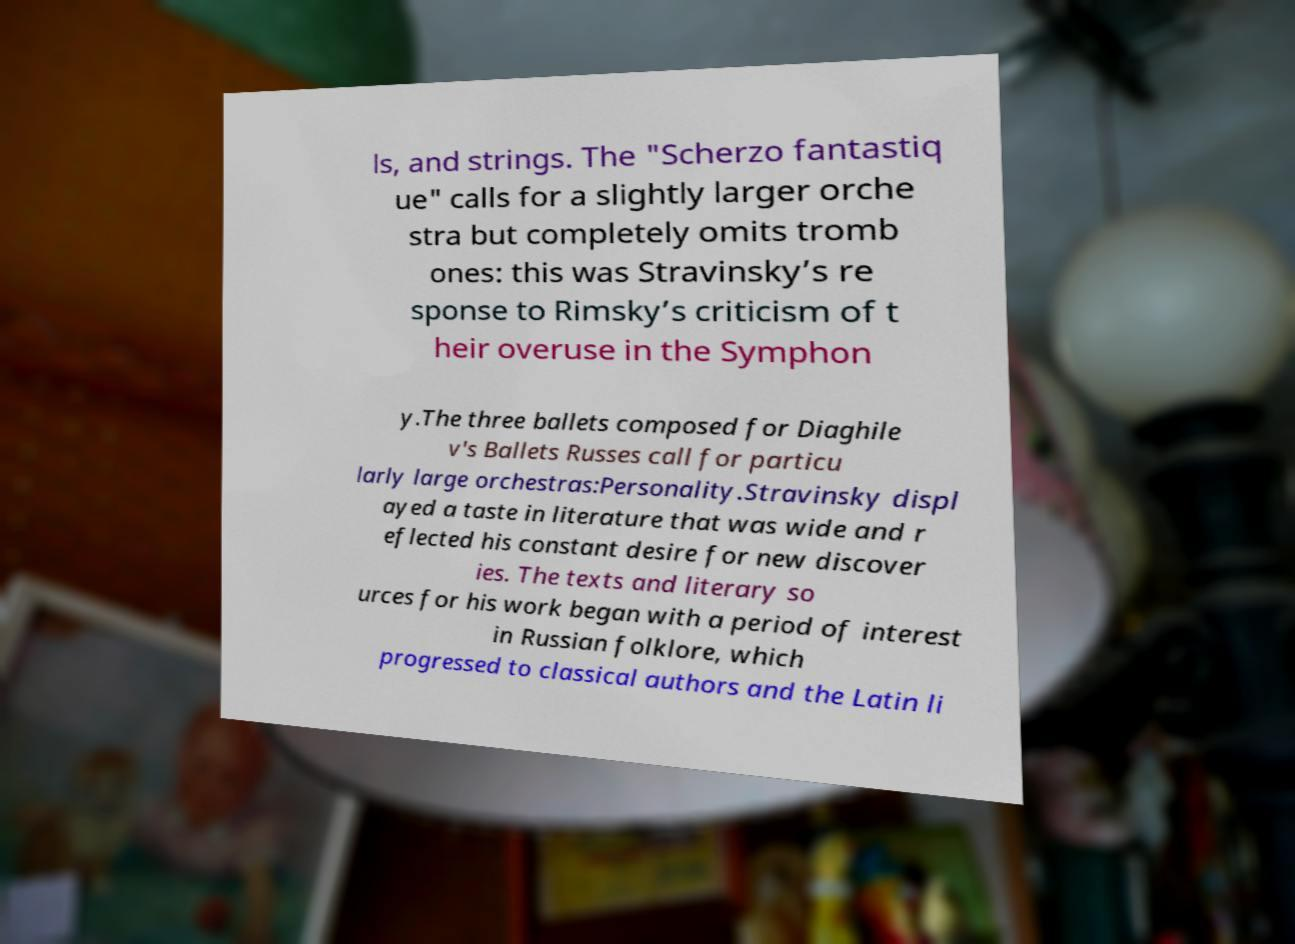What messages or text are displayed in this image? I need them in a readable, typed format. ls, and strings. The "Scherzo fantastiq ue" calls for a slightly larger orche stra but completely omits tromb ones: this was Stravinsky’s re sponse to Rimsky’s criticism of t heir overuse in the Symphon y.The three ballets composed for Diaghile v's Ballets Russes call for particu larly large orchestras:Personality.Stravinsky displ ayed a taste in literature that was wide and r eflected his constant desire for new discover ies. The texts and literary so urces for his work began with a period of interest in Russian folklore, which progressed to classical authors and the Latin li 